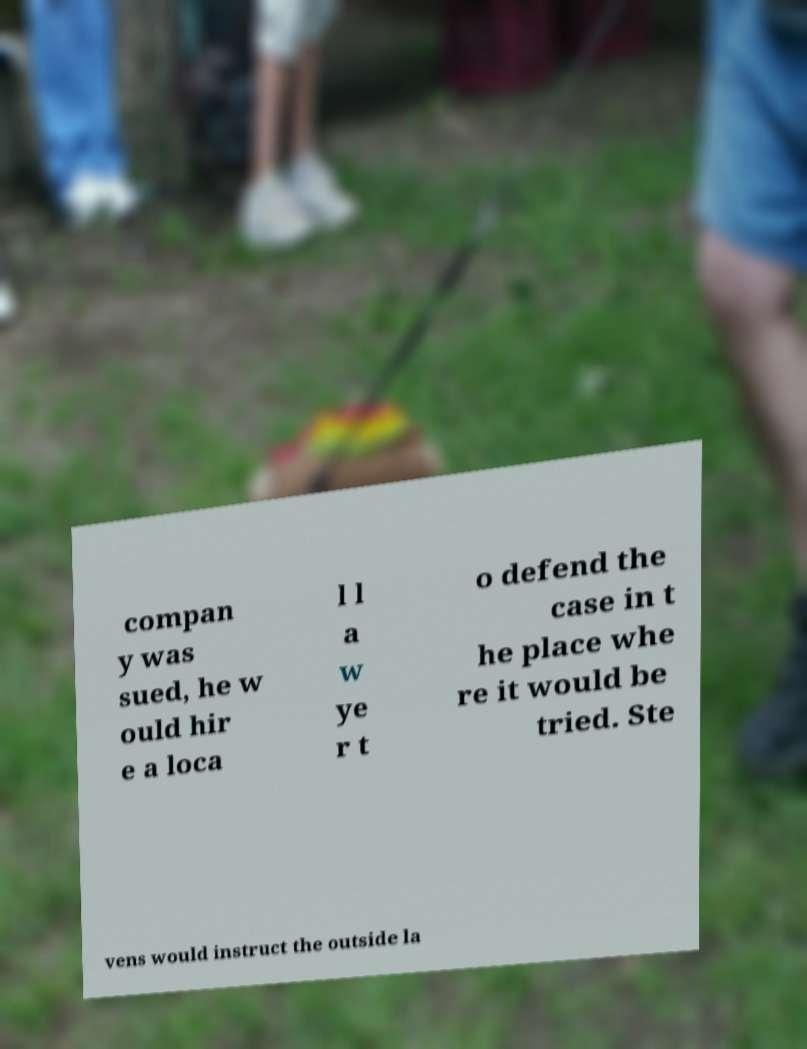Please read and relay the text visible in this image. What does it say? compan y was sued, he w ould hir e a loca l l a w ye r t o defend the case in t he place whe re it would be tried. Ste vens would instruct the outside la 